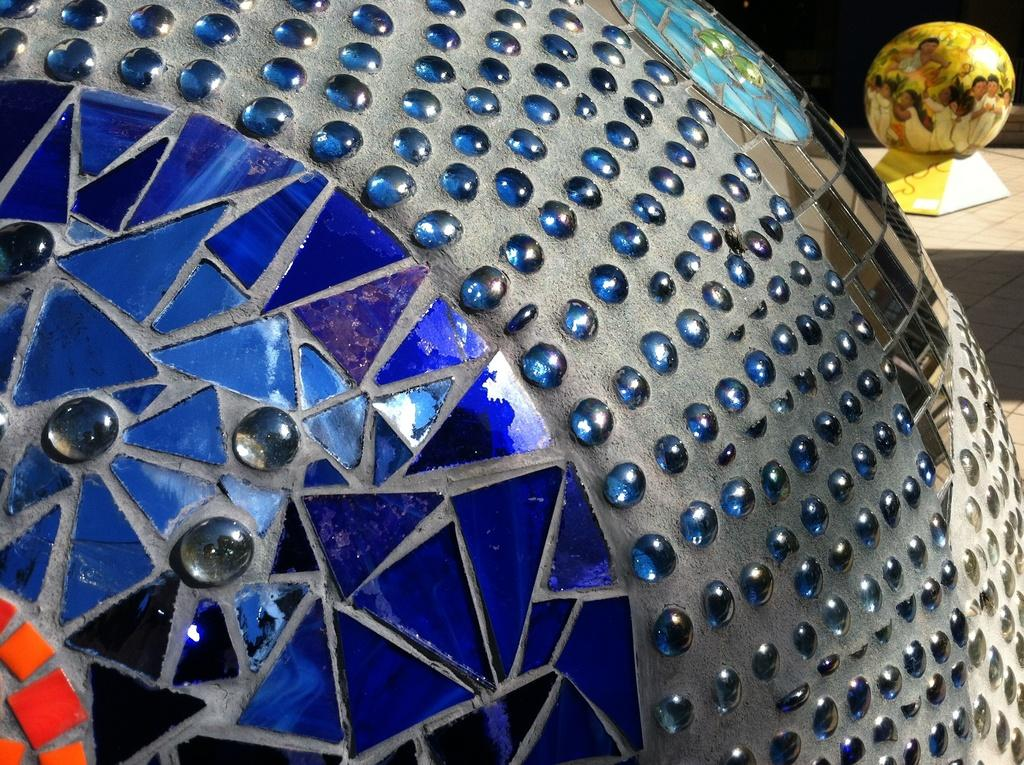What shape is the main object in the image? The main object in the image is a spherical object. What colors and materials can be seen on the spherical object? The spherical object has orange, blue, and other glass materials on it. Can you describe the second spherical object in the image? The second spherical object is at the top right of the image and is also spherical. Where is the second spherical object located? The second spherical object is on a table-like surface. How much tax is being paid on the spherical objects in the image? There is no mention of tax or any financial transaction in the image, so it cannot be determined. 